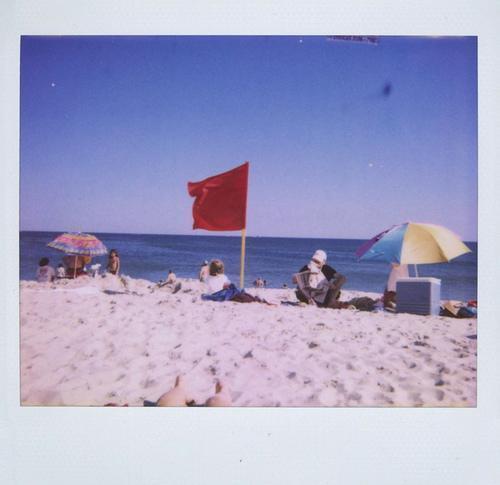How many umbrellas are there in this picture?
Give a very brief answer. 2. How many people are on the boat not at the dock?
Give a very brief answer. 0. 